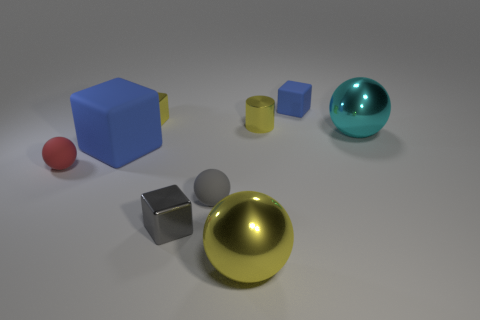How many things are either tiny purple spheres or tiny blue rubber things?
Give a very brief answer. 1. What is the size of the blue rubber object that is behind the large blue cube?
Provide a succinct answer. Small. There is a big thing that is in front of the small ball to the left of the large blue matte cube; what number of large cyan shiny objects are behind it?
Give a very brief answer. 1. Do the large cube and the tiny rubber block have the same color?
Offer a terse response. Yes. How many balls are both behind the big yellow sphere and in front of the large matte thing?
Your response must be concise. 2. There is a big thing that is to the right of the cylinder; what is its shape?
Offer a terse response. Sphere. Is the number of metallic things that are right of the tiny blue thing less than the number of tiny balls that are behind the large rubber thing?
Give a very brief answer. No. Does the blue cube on the left side of the small gray metal cube have the same material as the cylinder right of the large matte thing?
Offer a terse response. No. What is the shape of the large cyan shiny object?
Offer a very short reply. Sphere. Is the number of small yellow things on the left side of the large yellow metal sphere greater than the number of tiny yellow objects left of the cylinder?
Offer a very short reply. No. 